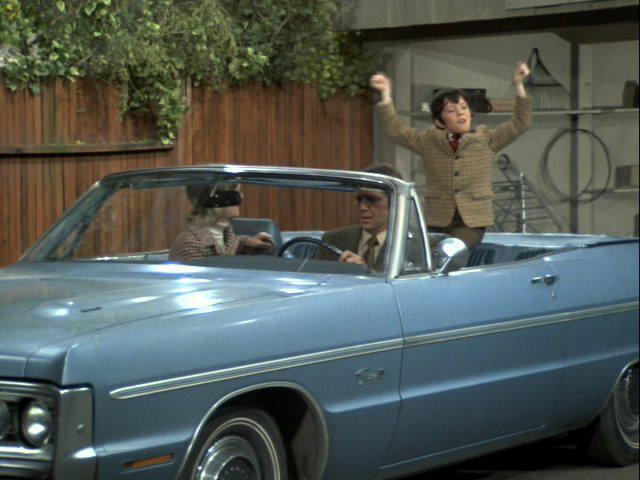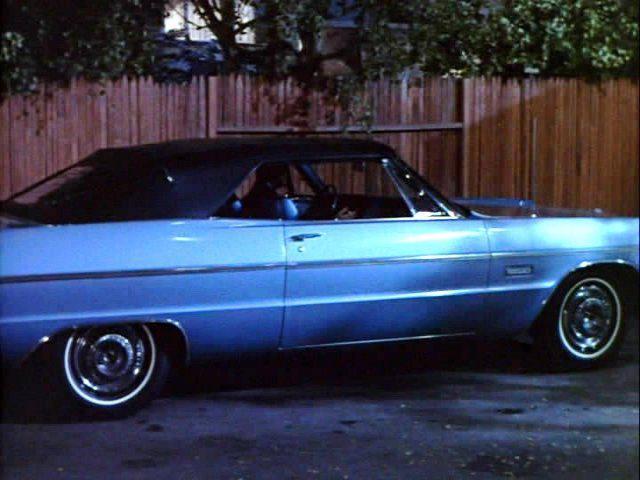The first image is the image on the left, the second image is the image on the right. Evaluate the accuracy of this statement regarding the images: "Two cars have convertible tops and have small wing windows beside the windshield.". Is it true? Answer yes or no. Yes. The first image is the image on the left, the second image is the image on the right. For the images displayed, is the sentence "An image shows at least two people in a blue convertible with the top down, next to a privacy fence." factually correct? Answer yes or no. Yes. 